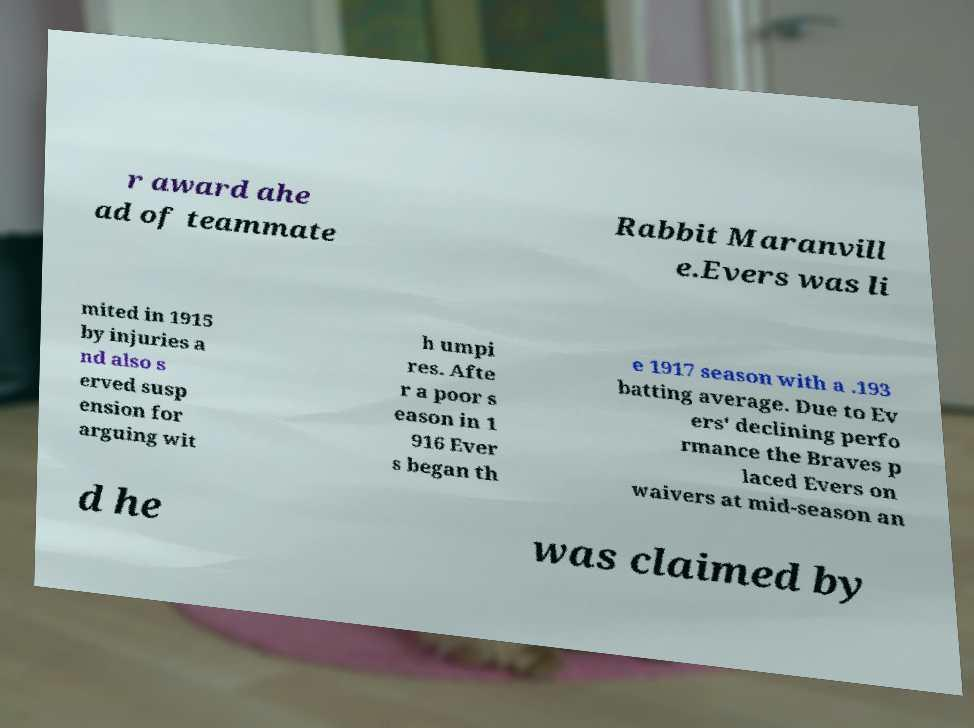What messages or text are displayed in this image? I need them in a readable, typed format. r award ahe ad of teammate Rabbit Maranvill e.Evers was li mited in 1915 by injuries a nd also s erved susp ension for arguing wit h umpi res. Afte r a poor s eason in 1 916 Ever s began th e 1917 season with a .193 batting average. Due to Ev ers' declining perfo rmance the Braves p laced Evers on waivers at mid-season an d he was claimed by 